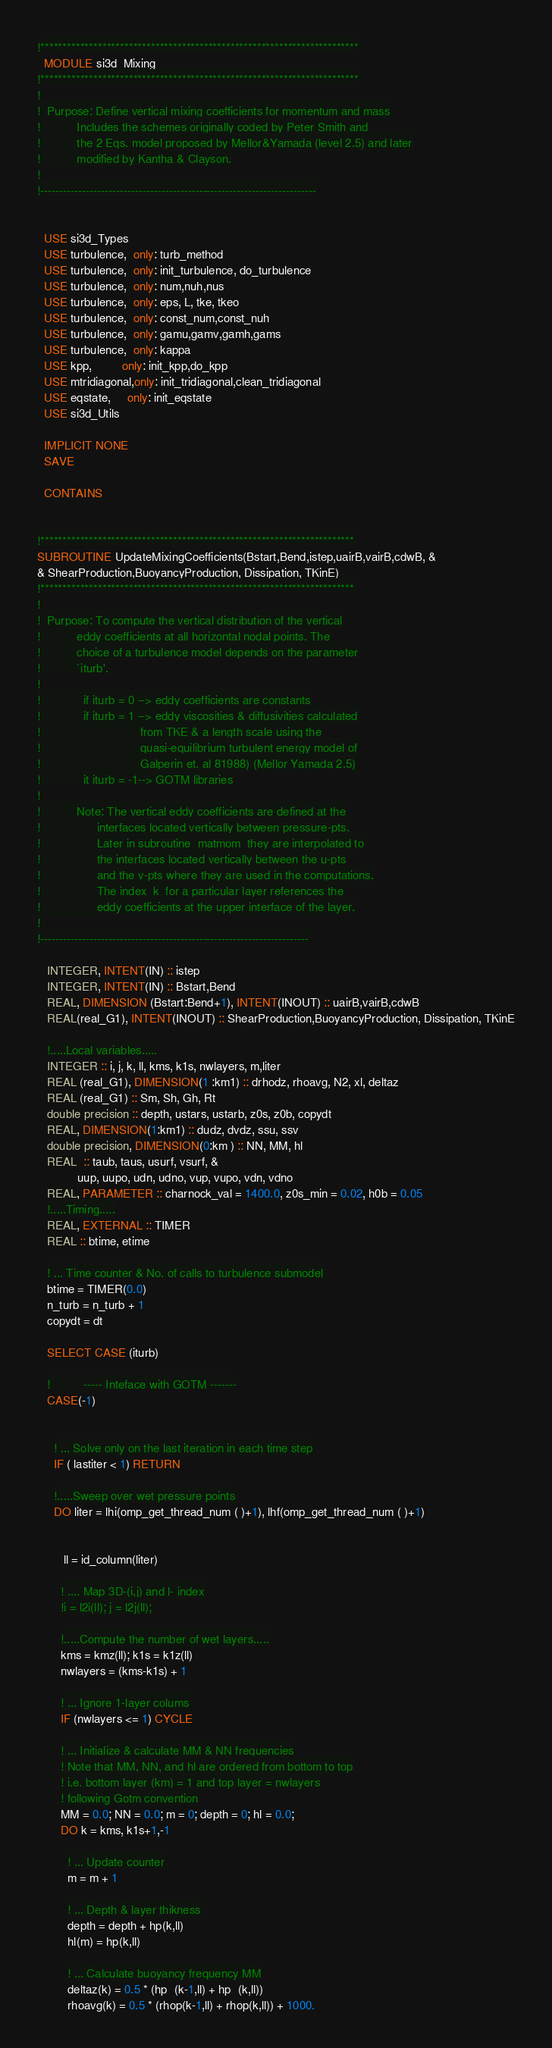Convert code to text. <code><loc_0><loc_0><loc_500><loc_500><_FORTRAN_>!************************************************************************
  MODULE si3d_Mixing
!************************************************************************
!
!  Purpose: Define vertical mixing coefficients for momentum and mass
!           Includes the schemes originally coded by Peter Smith and
!           the 2 Eqs. model proposed by Mellor&Yamada (level 2.5) and later
!           modified by Kantha & Clayson.
!
!-------------------------------------------------------------------------


  USE si3d_Types
  USE turbulence,  only: turb_method
  USE turbulence,  only: init_turbulence, do_turbulence
  USE turbulence,  only: num,nuh,nus
  USE turbulence,  only: eps, L, tke, tkeo
  USE turbulence,  only: const_num,const_nuh
  USE turbulence,  only: gamu,gamv,gamh,gams
  USE turbulence,  only: kappa
  USE kpp,         only: init_kpp,do_kpp
  USE mtridiagonal,only: init_tridiagonal,clean_tridiagonal
  USE eqstate,     only: init_eqstate
  USE si3d_Utils

  IMPLICIT NONE
  SAVE

  CONTAINS


!***********************************************************************
SUBROUTINE UpdateMixingCoefficients(Bstart,Bend,istep,uairB,vairB,cdwB, &
& ShearProduction,BuoyancyProduction, Dissipation, TKinE)
!***********************************************************************
!
!  Purpose: To compute the vertical distribution of the vertical
!           eddy coefficients at all horizontal nodal points. The
!           choice of a turbulence model depends on the parameter
!           `iturb'.
!
!             if iturb = 0 --> eddy coefficients are constants
!             if iturb = 1 --> eddy viscosities & diffusivities calculated
!                              from TKE & a length scale using the
!                              quasi-equilibrium turbulent energy model of
!                              Galperin et. al 81988) (Mellor Yamada 2.5)
!             it iturb = -1--> GOTM libraries
!
!           Note: The vertical eddy coefficients are defined at the
!                 interfaces located vertically between pressure-pts.
!                 Later in subroutine  matmom  they are interpolated to
!                 the interfaces located vertically between the u-pts
!                 and the v-pts where they are used in the computations.
!                 The index  k  for a particular layer references the
!                 eddy coefficients at the upper interface of the layer.
!
!-----------------------------------------------------------------------

   INTEGER, INTENT(IN) :: istep
   INTEGER, INTENT(IN) :: Bstart,Bend
   REAL, DIMENSION (Bstart:Bend+1), INTENT(INOUT) :: uairB,vairB,cdwB
   REAL(real_G1), INTENT(INOUT) :: ShearProduction,BuoyancyProduction, Dissipation, TKinE

   !.....Local variables.....
   INTEGER :: i, j, k, ll, kms, k1s, nwlayers, m,liter
   REAL (real_G1), DIMENSION(1 :km1) :: drhodz, rhoavg, N2, xl, deltaz
   REAL (real_G1) :: Sm, Sh, Gh, Rt
   double precision :: depth, ustars, ustarb, z0s, z0b, copydt
   REAL, DIMENSION(1:km1) :: dudz, dvdz, ssu, ssv
   double precision, DIMENSION(0:km ) :: NN, MM, hl
   REAL  :: taub, taus, usurf, vsurf, &
            uup, uupo, udn, udno, vup, vupo, vdn, vdno
   REAL, PARAMETER :: charnock_val = 1400.0, z0s_min = 0.02, h0b = 0.05
   !.....Timing.....
   REAL, EXTERNAL :: TIMER
   REAL :: btime, etime

   ! ... Time counter & No. of calls to turbulence submodel
   btime = TIMER(0.0)
   n_turb = n_turb + 1
   copydt = dt

   SELECT CASE (iturb)

   !          ----- Inteface with GOTM -------
   CASE(-1)


     ! ... Solve only on the last iteration in each time step
     IF ( lastiter < 1) RETURN

     !.....Sweep over wet pressure points
     DO liter = lhi(omp_get_thread_num ( )+1), lhf(omp_get_thread_num ( )+1)


        ll = id_column(liter)

       ! .... Map 3D-(i,j) and l- index
       !i = l2i(ll); j = l2j(ll);

       !.....Compute the number of wet layers.....
       kms = kmz(ll); k1s = k1z(ll)
       nwlayers = (kms-k1s) + 1

       ! ... Ignore 1-layer colums
       IF (nwlayers <= 1) CYCLE

       ! ... Initialize & calculate MM & NN frequencies
       ! Note that MM, NN, and hl are ordered from bottom to top
       ! i.e. bottom layer (km) = 1 and top layer = nwlayers
       ! following Gotm convention
       MM = 0.0; NN = 0.0; m = 0; depth = 0; hl = 0.0;
       DO k = kms, k1s+1,-1

         ! ... Update counter
         m = m + 1

         ! ... Depth & layer thikness
         depth = depth + hp(k,ll)
         hl(m) = hp(k,ll)

         ! ... Calculate buoyancy frequency MM
         deltaz(k) = 0.5 * (hp  (k-1,ll) + hp  (k,ll))
         rhoavg(k) = 0.5 * (rhop(k-1,ll) + rhop(k,ll)) + 1000.</code> 